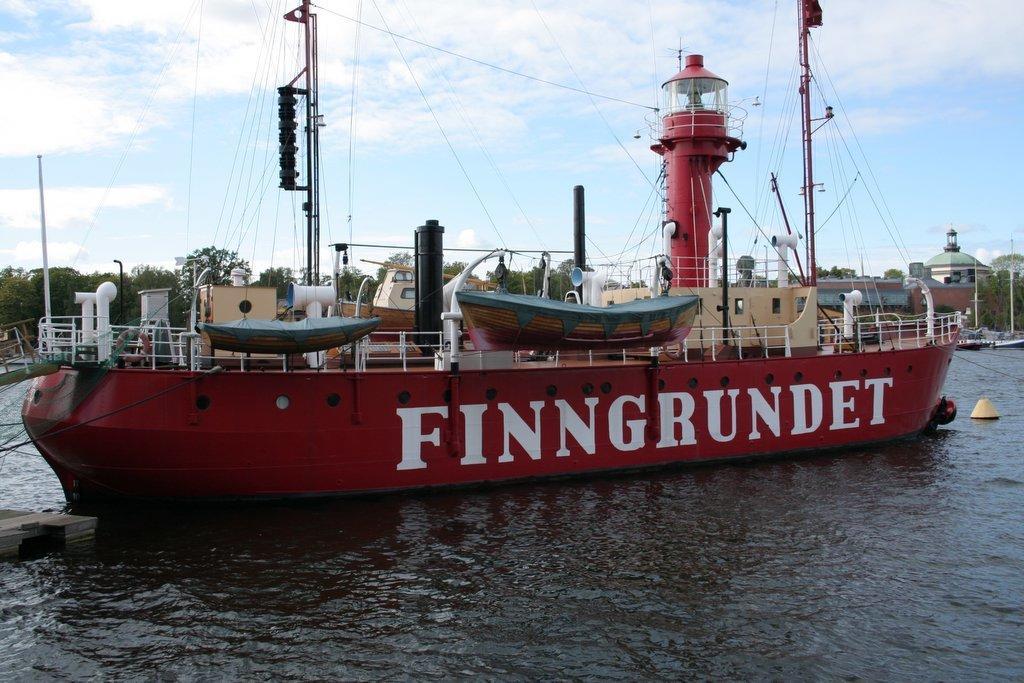In one or two sentences, can you explain what this image depicts? Here we can see a ship on the water and we can see poles with strings. Background we can see trees and sky. 